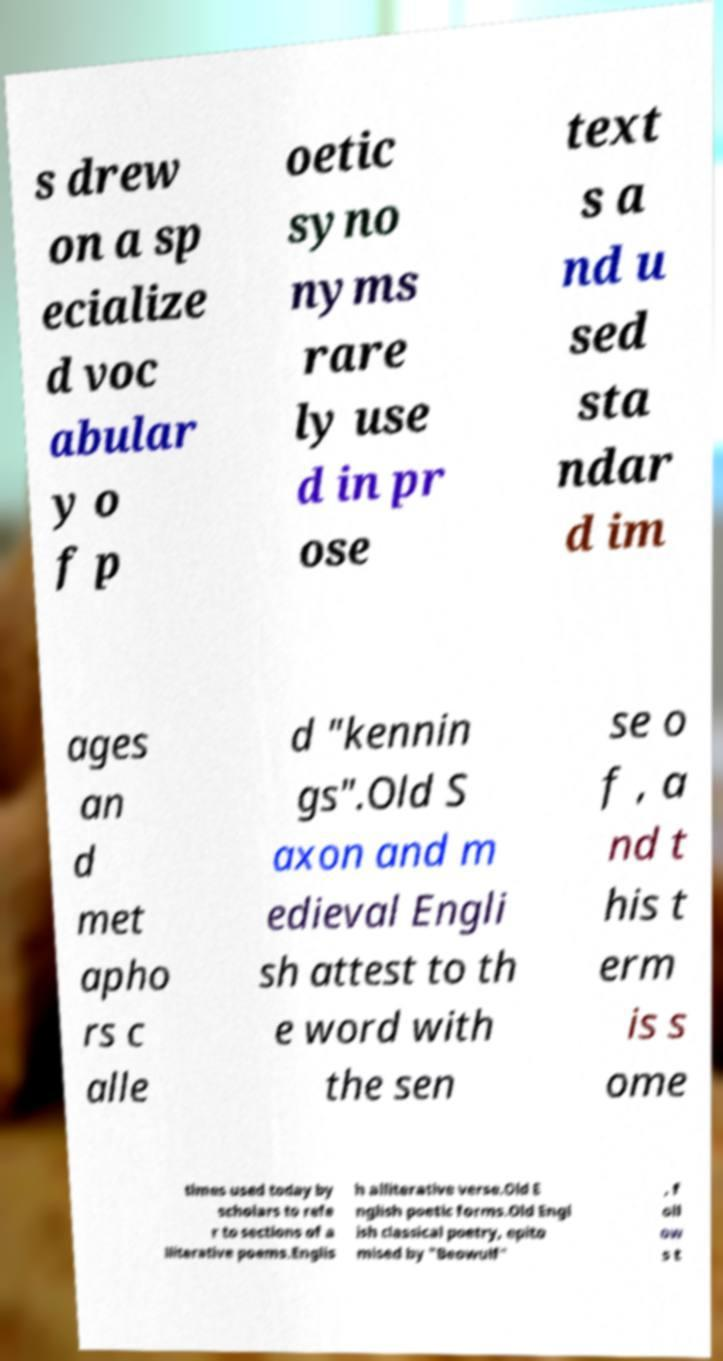For documentation purposes, I need the text within this image transcribed. Could you provide that? s drew on a sp ecialize d voc abular y o f p oetic syno nyms rare ly use d in pr ose text s a nd u sed sta ndar d im ages an d met apho rs c alle d "kennin gs".Old S axon and m edieval Engli sh attest to th e word with the sen se o f , a nd t his t erm is s ome times used today by scholars to refe r to sections of a lliterative poems.Englis h alliterative verse.Old E nglish poetic forms.Old Engl ish classical poetry, epito mised by "Beowulf" , f oll ow s t 